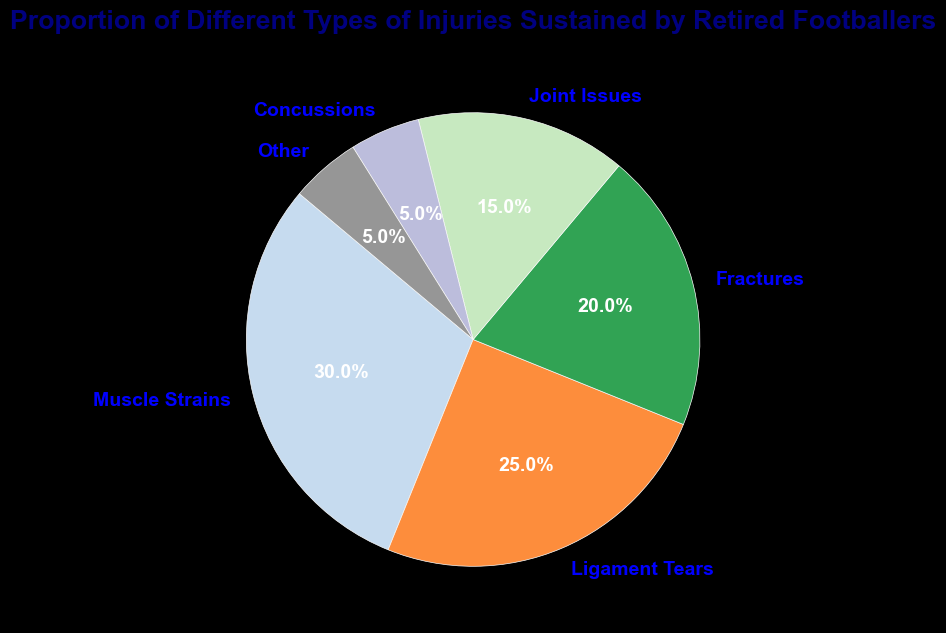Which injury type has the highest proportion? Looking at the pie chart, each segment's proportion is labeled. The 'Muscle Strains' segment has the highest proportion of 30%.
Answer: Muscle Strains What is the combined proportion of Ligament Tears and Joint Issues? Adding the proportions of 'Ligament Tears' (25%) and 'Joint Issues' (15%), we get 25% + 15% = 40%.
Answer: 40% Which injury types have the same proportion? Observing the pie chart, 'Concussions' and 'Other' both have the same proportion of 5%.
Answer: Concussions and Other How much greater is the proportion of Muscle Strains compared to Fractures? Subtracting the proportion of 'Fractures' (20%) from 'Muscle Strains' (30%), we get 30% - 20% = 10%.
Answer: 10% What percentage of injuries are not related to muscle strains, ligament tears, or fractures? Summing the proportions of 'Joint Issues' (15%), 'Concussions' (5%), and 'Other' (5%), we get 15% + 5% + 5% = 25%.
Answer: 25% Is the proportion of Muscle Strains more than the combined proportion of Concussions and Other? Adding the proportions of 'Concussions' (5%) and 'Other' (5%), we get 5% + 5% = 10%. The proportion of 'Muscle Strains' is 30%, which is greater than 10%.
Answer: Yes What is the second most common type of injury? The pie chart shows that 'Ligament Tears' has the second highest proportion at 25%.
Answer: Ligament Tears Are joint-related issues (Joint Issues + Ligament Tears) a majority of the injuries? Summing the proportions of 'Joint Issues' (15%) and 'Ligament Tears' (25%), we get 15% + 25% = 40%. Since 40% is less than 50%, joint-related issues are not a majority.
Answer: No By how much does the proportion of Joint Issues exceed that of Concussions? Subtracting the proportion of 'Concussions' (5%) from 'Joint Issues' (15%), we get 15% - 5% = 10%.
Answer: 10% 